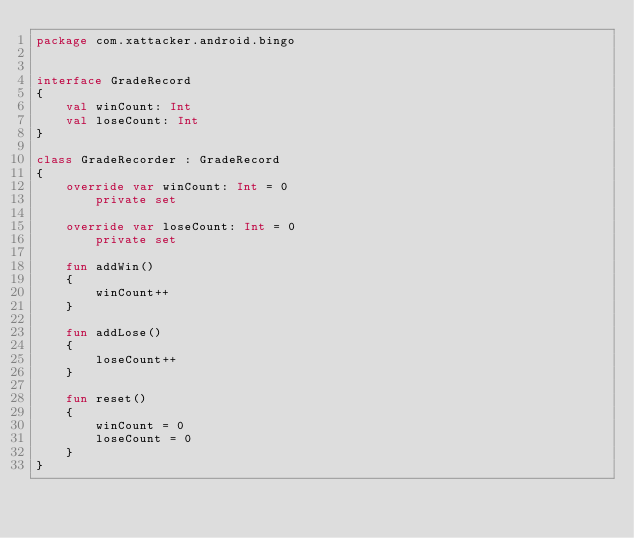<code> <loc_0><loc_0><loc_500><loc_500><_Kotlin_>package com.xattacker.android.bingo


interface GradeRecord
{
    val winCount: Int
    val loseCount: Int
}

class GradeRecorder : GradeRecord
{
    override var winCount: Int = 0
        private set

    override var loseCount: Int = 0
        private set

    fun addWin()
    {
        winCount++
    }

    fun addLose()
    {
        loseCount++
    }

    fun reset()
    {
        winCount = 0
        loseCount = 0
    }
}
</code> 